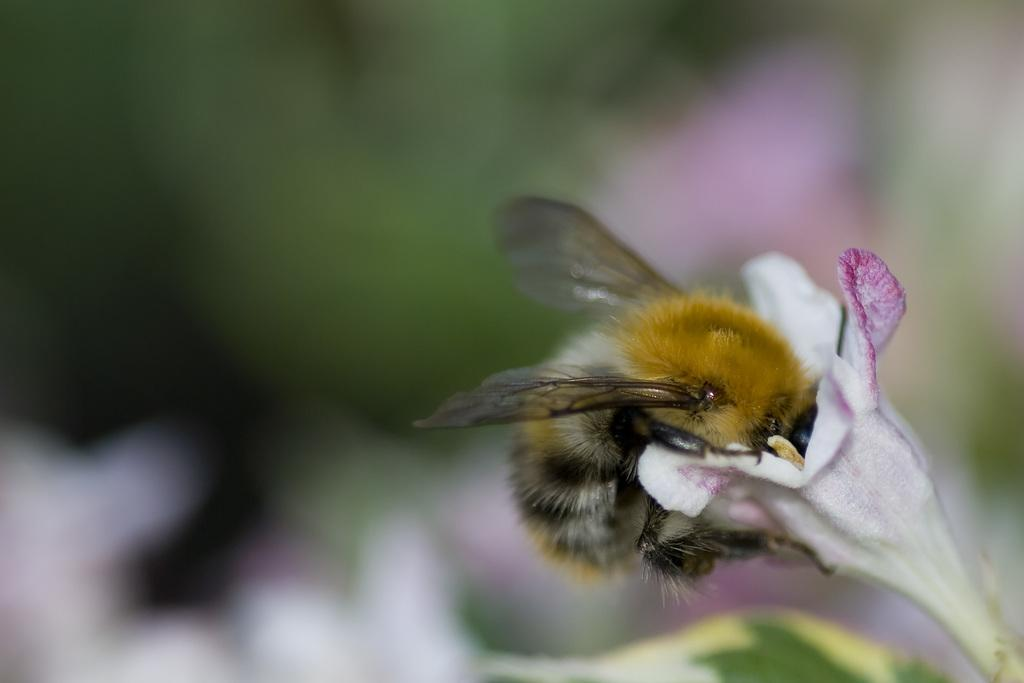What type of creature can be seen in the image? There is an insect in the image. Where is the insect located in the image? The insect is on a flower. What type of vest is the actor wearing in the image? There is no actor or vest present in the image; it features an insect on a flower. What type of luggage is the porter carrying in the image? There is no porter or luggage present in the image; it features an insect on a flower. 